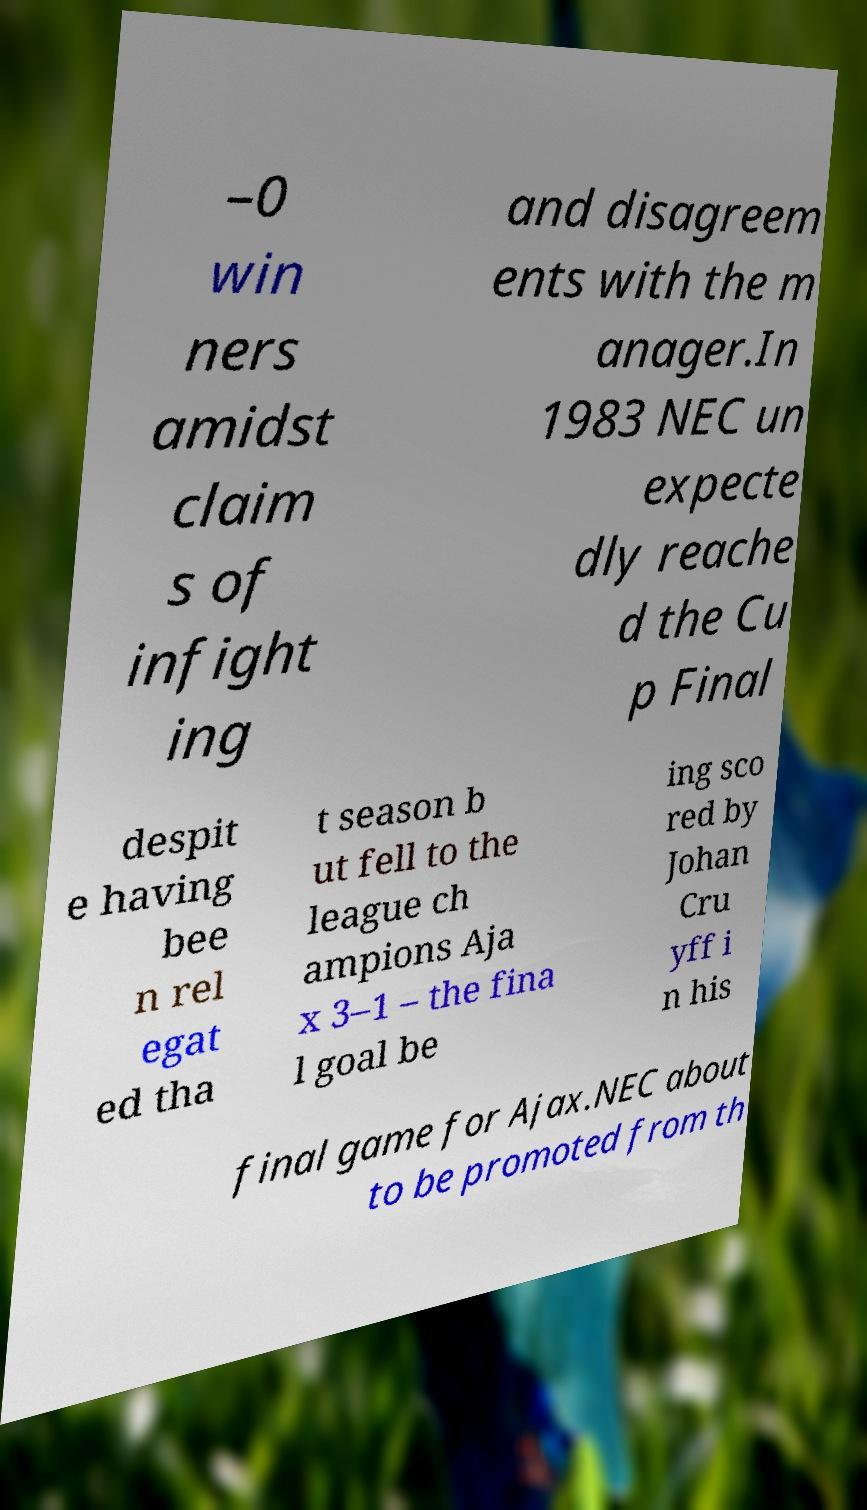For documentation purposes, I need the text within this image transcribed. Could you provide that? –0 win ners amidst claim s of infight ing and disagreem ents with the m anager.In 1983 NEC un expecte dly reache d the Cu p Final despit e having bee n rel egat ed tha t season b ut fell to the league ch ampions Aja x 3–1 – the fina l goal be ing sco red by Johan Cru yff i n his final game for Ajax.NEC about to be promoted from th 